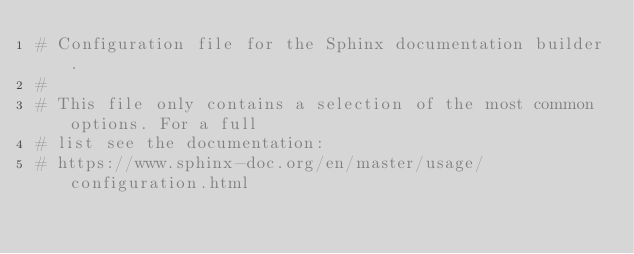Convert code to text. <code><loc_0><loc_0><loc_500><loc_500><_Python_># Configuration file for the Sphinx documentation builder.
#
# This file only contains a selection of the most common options. For a full
# list see the documentation:
# https://www.sphinx-doc.org/en/master/usage/configuration.html
</code> 